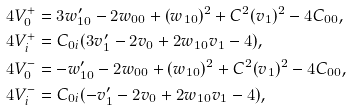Convert formula to latex. <formula><loc_0><loc_0><loc_500><loc_500>4 V _ { 0 } ^ { + } & = 3 w ^ { \prime } _ { 1 0 } - 2 w _ { 0 0 } + ( w _ { 1 0 } ) ^ { 2 } + C ^ { 2 } ( v _ { 1 } ) ^ { 2 } - 4 C _ { 0 0 } , \\ 4 V _ { i } ^ { + } & = C _ { 0 i } ( 3 v ^ { \prime } _ { 1 } - 2 v _ { 0 } + 2 w _ { 1 0 } v _ { 1 } - 4 ) , \\ 4 V _ { 0 } ^ { - } & = - w ^ { \prime } _ { 1 0 } - 2 w _ { 0 0 } + ( w _ { 1 0 } ) ^ { 2 } + C ^ { 2 } ( v _ { 1 } ) ^ { 2 } - 4 C _ { 0 0 } , \\ 4 V _ { i } ^ { - } & = C _ { 0 i } ( - v ^ { \prime } _ { 1 } - 2 v _ { 0 } + 2 w _ { 1 0 } v _ { 1 } - 4 ) ,</formula> 